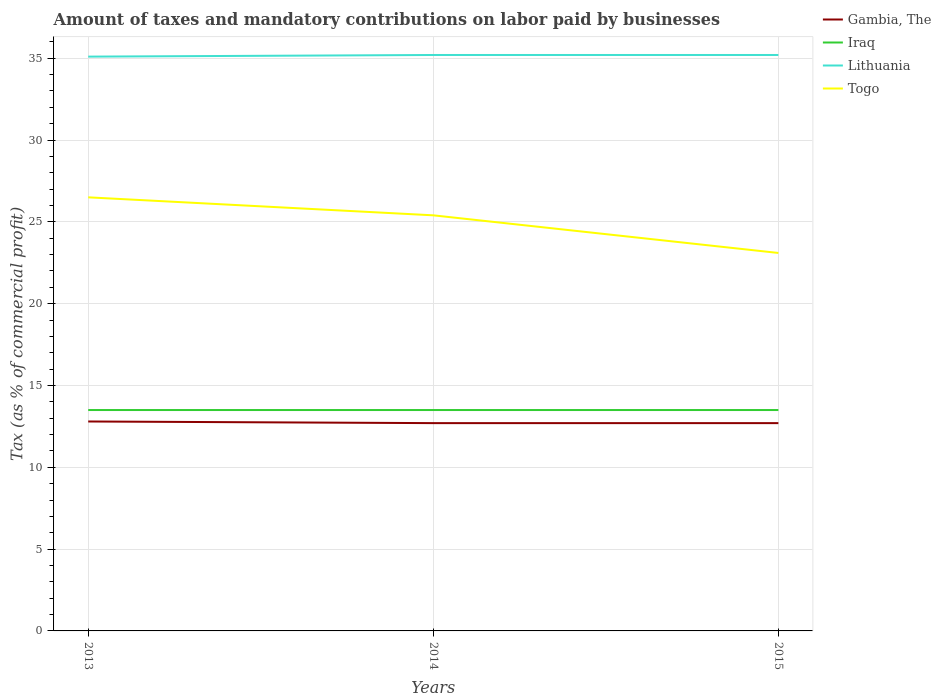Does the line corresponding to Iraq intersect with the line corresponding to Gambia, The?
Make the answer very short. No. Across all years, what is the maximum percentage of taxes paid by businesses in Togo?
Offer a very short reply. 23.1. In which year was the percentage of taxes paid by businesses in Togo maximum?
Your answer should be compact. 2015. What is the total percentage of taxes paid by businesses in Togo in the graph?
Your response must be concise. 2.3. What is the difference between the highest and the second highest percentage of taxes paid by businesses in Lithuania?
Your response must be concise. 0.1. Is the percentage of taxes paid by businesses in Gambia, The strictly greater than the percentage of taxes paid by businesses in Togo over the years?
Keep it short and to the point. Yes. Does the graph contain any zero values?
Keep it short and to the point. No. Does the graph contain grids?
Your answer should be compact. Yes. Where does the legend appear in the graph?
Your response must be concise. Top right. How many legend labels are there?
Keep it short and to the point. 4. What is the title of the graph?
Your response must be concise. Amount of taxes and mandatory contributions on labor paid by businesses. Does "Middle East & North Africa (all income levels)" appear as one of the legend labels in the graph?
Offer a terse response. No. What is the label or title of the Y-axis?
Offer a very short reply. Tax (as % of commercial profit). What is the Tax (as % of commercial profit) in Gambia, The in 2013?
Give a very brief answer. 12.8. What is the Tax (as % of commercial profit) of Lithuania in 2013?
Your response must be concise. 35.1. What is the Tax (as % of commercial profit) in Gambia, The in 2014?
Your answer should be very brief. 12.7. What is the Tax (as % of commercial profit) in Lithuania in 2014?
Your answer should be compact. 35.2. What is the Tax (as % of commercial profit) in Togo in 2014?
Your answer should be compact. 25.4. What is the Tax (as % of commercial profit) of Lithuania in 2015?
Keep it short and to the point. 35.2. What is the Tax (as % of commercial profit) in Togo in 2015?
Make the answer very short. 23.1. Across all years, what is the maximum Tax (as % of commercial profit) in Gambia, The?
Offer a very short reply. 12.8. Across all years, what is the maximum Tax (as % of commercial profit) in Lithuania?
Keep it short and to the point. 35.2. Across all years, what is the maximum Tax (as % of commercial profit) in Togo?
Your response must be concise. 26.5. Across all years, what is the minimum Tax (as % of commercial profit) in Iraq?
Offer a terse response. 13.5. Across all years, what is the minimum Tax (as % of commercial profit) in Lithuania?
Provide a succinct answer. 35.1. Across all years, what is the minimum Tax (as % of commercial profit) in Togo?
Your response must be concise. 23.1. What is the total Tax (as % of commercial profit) in Gambia, The in the graph?
Offer a very short reply. 38.2. What is the total Tax (as % of commercial profit) of Iraq in the graph?
Your answer should be compact. 40.5. What is the total Tax (as % of commercial profit) in Lithuania in the graph?
Your answer should be compact. 105.5. What is the total Tax (as % of commercial profit) of Togo in the graph?
Provide a succinct answer. 75. What is the difference between the Tax (as % of commercial profit) in Iraq in 2013 and that in 2014?
Offer a very short reply. 0. What is the difference between the Tax (as % of commercial profit) in Gambia, The in 2013 and that in 2015?
Ensure brevity in your answer.  0.1. What is the difference between the Tax (as % of commercial profit) of Iraq in 2013 and that in 2015?
Give a very brief answer. 0. What is the difference between the Tax (as % of commercial profit) of Lithuania in 2013 and that in 2015?
Ensure brevity in your answer.  -0.1. What is the difference between the Tax (as % of commercial profit) of Gambia, The in 2014 and that in 2015?
Your response must be concise. 0. What is the difference between the Tax (as % of commercial profit) of Iraq in 2014 and that in 2015?
Your answer should be compact. 0. What is the difference between the Tax (as % of commercial profit) in Lithuania in 2014 and that in 2015?
Offer a very short reply. 0. What is the difference between the Tax (as % of commercial profit) in Gambia, The in 2013 and the Tax (as % of commercial profit) in Lithuania in 2014?
Your answer should be compact. -22.4. What is the difference between the Tax (as % of commercial profit) of Iraq in 2013 and the Tax (as % of commercial profit) of Lithuania in 2014?
Offer a terse response. -21.7. What is the difference between the Tax (as % of commercial profit) in Lithuania in 2013 and the Tax (as % of commercial profit) in Togo in 2014?
Ensure brevity in your answer.  9.7. What is the difference between the Tax (as % of commercial profit) of Gambia, The in 2013 and the Tax (as % of commercial profit) of Iraq in 2015?
Offer a very short reply. -0.7. What is the difference between the Tax (as % of commercial profit) in Gambia, The in 2013 and the Tax (as % of commercial profit) in Lithuania in 2015?
Keep it short and to the point. -22.4. What is the difference between the Tax (as % of commercial profit) of Iraq in 2013 and the Tax (as % of commercial profit) of Lithuania in 2015?
Keep it short and to the point. -21.7. What is the difference between the Tax (as % of commercial profit) in Gambia, The in 2014 and the Tax (as % of commercial profit) in Lithuania in 2015?
Your answer should be very brief. -22.5. What is the difference between the Tax (as % of commercial profit) in Iraq in 2014 and the Tax (as % of commercial profit) in Lithuania in 2015?
Provide a short and direct response. -21.7. What is the difference between the Tax (as % of commercial profit) in Iraq in 2014 and the Tax (as % of commercial profit) in Togo in 2015?
Give a very brief answer. -9.6. What is the difference between the Tax (as % of commercial profit) in Lithuania in 2014 and the Tax (as % of commercial profit) in Togo in 2015?
Offer a very short reply. 12.1. What is the average Tax (as % of commercial profit) in Gambia, The per year?
Your response must be concise. 12.73. What is the average Tax (as % of commercial profit) of Iraq per year?
Make the answer very short. 13.5. What is the average Tax (as % of commercial profit) of Lithuania per year?
Keep it short and to the point. 35.17. In the year 2013, what is the difference between the Tax (as % of commercial profit) of Gambia, The and Tax (as % of commercial profit) of Iraq?
Give a very brief answer. -0.7. In the year 2013, what is the difference between the Tax (as % of commercial profit) in Gambia, The and Tax (as % of commercial profit) in Lithuania?
Make the answer very short. -22.3. In the year 2013, what is the difference between the Tax (as % of commercial profit) of Gambia, The and Tax (as % of commercial profit) of Togo?
Offer a terse response. -13.7. In the year 2013, what is the difference between the Tax (as % of commercial profit) in Iraq and Tax (as % of commercial profit) in Lithuania?
Ensure brevity in your answer.  -21.6. In the year 2013, what is the difference between the Tax (as % of commercial profit) of Iraq and Tax (as % of commercial profit) of Togo?
Make the answer very short. -13. In the year 2014, what is the difference between the Tax (as % of commercial profit) of Gambia, The and Tax (as % of commercial profit) of Iraq?
Your answer should be compact. -0.8. In the year 2014, what is the difference between the Tax (as % of commercial profit) of Gambia, The and Tax (as % of commercial profit) of Lithuania?
Provide a short and direct response. -22.5. In the year 2014, what is the difference between the Tax (as % of commercial profit) in Gambia, The and Tax (as % of commercial profit) in Togo?
Provide a short and direct response. -12.7. In the year 2014, what is the difference between the Tax (as % of commercial profit) of Iraq and Tax (as % of commercial profit) of Lithuania?
Ensure brevity in your answer.  -21.7. In the year 2014, what is the difference between the Tax (as % of commercial profit) in Iraq and Tax (as % of commercial profit) in Togo?
Keep it short and to the point. -11.9. In the year 2014, what is the difference between the Tax (as % of commercial profit) of Lithuania and Tax (as % of commercial profit) of Togo?
Keep it short and to the point. 9.8. In the year 2015, what is the difference between the Tax (as % of commercial profit) of Gambia, The and Tax (as % of commercial profit) of Iraq?
Your answer should be compact. -0.8. In the year 2015, what is the difference between the Tax (as % of commercial profit) in Gambia, The and Tax (as % of commercial profit) in Lithuania?
Offer a very short reply. -22.5. In the year 2015, what is the difference between the Tax (as % of commercial profit) of Iraq and Tax (as % of commercial profit) of Lithuania?
Offer a very short reply. -21.7. In the year 2015, what is the difference between the Tax (as % of commercial profit) of Lithuania and Tax (as % of commercial profit) of Togo?
Provide a short and direct response. 12.1. What is the ratio of the Tax (as % of commercial profit) in Gambia, The in 2013 to that in 2014?
Your answer should be compact. 1.01. What is the ratio of the Tax (as % of commercial profit) of Togo in 2013 to that in 2014?
Offer a terse response. 1.04. What is the ratio of the Tax (as % of commercial profit) in Gambia, The in 2013 to that in 2015?
Give a very brief answer. 1.01. What is the ratio of the Tax (as % of commercial profit) of Iraq in 2013 to that in 2015?
Your answer should be very brief. 1. What is the ratio of the Tax (as % of commercial profit) in Togo in 2013 to that in 2015?
Your response must be concise. 1.15. What is the ratio of the Tax (as % of commercial profit) of Lithuania in 2014 to that in 2015?
Offer a terse response. 1. What is the ratio of the Tax (as % of commercial profit) of Togo in 2014 to that in 2015?
Ensure brevity in your answer.  1.1. What is the difference between the highest and the second highest Tax (as % of commercial profit) of Gambia, The?
Your answer should be very brief. 0.1. What is the difference between the highest and the second highest Tax (as % of commercial profit) in Iraq?
Keep it short and to the point. 0. What is the difference between the highest and the second highest Tax (as % of commercial profit) of Lithuania?
Your answer should be very brief. 0. What is the difference between the highest and the second highest Tax (as % of commercial profit) in Togo?
Your answer should be compact. 1.1. What is the difference between the highest and the lowest Tax (as % of commercial profit) in Togo?
Your answer should be very brief. 3.4. 